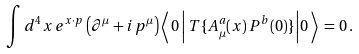<formula> <loc_0><loc_0><loc_500><loc_500>\int d ^ { 4 } x \, e ^ { x \cdot p } \left ( \partial ^ { \mu } + i \, p ^ { \mu } \right ) \left \langle \, 0 \left | \, T \{ A _ { \mu } ^ { a } ( x ) \, P ^ { b } ( 0 ) \} \right | 0 \, \right \rangle \, = \, 0 \, .</formula> 